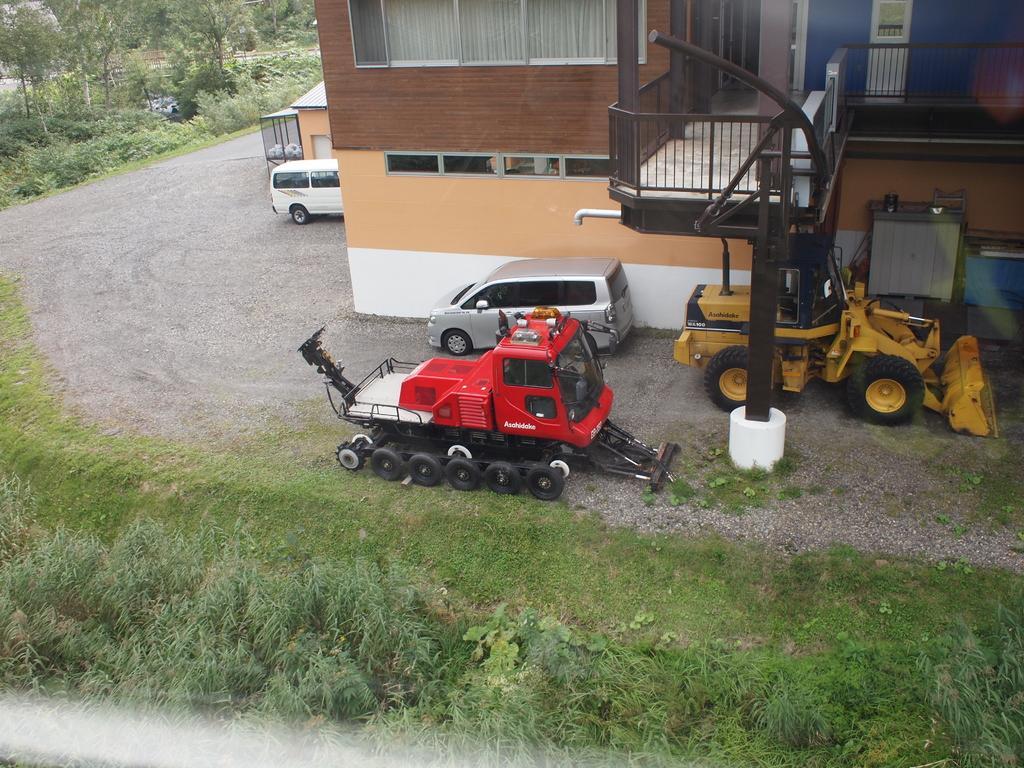Please provide a concise description of this image. In this image I can see few vehicles. In front the vehicle is in red color and I can also see the building in brown and cream color, few trees in green color. 